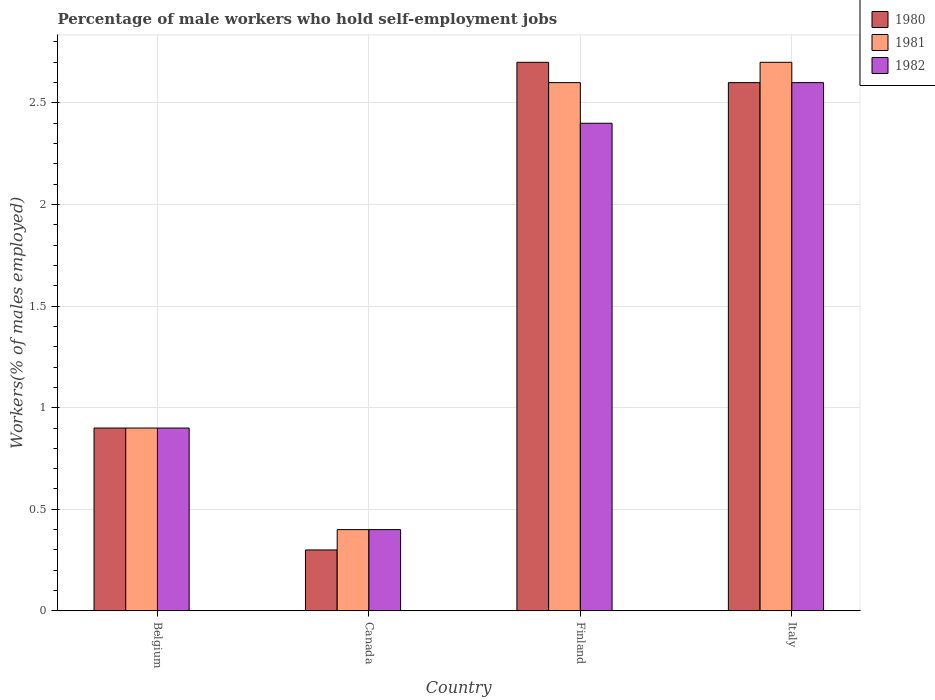How many different coloured bars are there?
Your response must be concise. 3. How many groups of bars are there?
Keep it short and to the point. 4. Are the number of bars per tick equal to the number of legend labels?
Your answer should be very brief. Yes. Are the number of bars on each tick of the X-axis equal?
Make the answer very short. Yes. How many bars are there on the 3rd tick from the left?
Offer a very short reply. 3. How many bars are there on the 1st tick from the right?
Your answer should be compact. 3. What is the label of the 3rd group of bars from the left?
Offer a terse response. Finland. In how many cases, is the number of bars for a given country not equal to the number of legend labels?
Provide a short and direct response. 0. What is the percentage of self-employed male workers in 1982 in Italy?
Offer a very short reply. 2.6. Across all countries, what is the maximum percentage of self-employed male workers in 1981?
Your response must be concise. 2.7. Across all countries, what is the minimum percentage of self-employed male workers in 1982?
Give a very brief answer. 0.4. In which country was the percentage of self-employed male workers in 1981 maximum?
Offer a very short reply. Italy. In which country was the percentage of self-employed male workers in 1982 minimum?
Provide a short and direct response. Canada. What is the total percentage of self-employed male workers in 1980 in the graph?
Keep it short and to the point. 6.5. What is the difference between the percentage of self-employed male workers in 1980 in Belgium and that in Finland?
Ensure brevity in your answer.  -1.8. What is the difference between the percentage of self-employed male workers in 1980 in Finland and the percentage of self-employed male workers in 1982 in Canada?
Provide a short and direct response. 2.3. What is the average percentage of self-employed male workers in 1980 per country?
Provide a succinct answer. 1.62. What is the difference between the percentage of self-employed male workers of/in 1982 and percentage of self-employed male workers of/in 1981 in Italy?
Provide a short and direct response. -0.1. What is the ratio of the percentage of self-employed male workers in 1981 in Belgium to that in Italy?
Your response must be concise. 0.33. Is the percentage of self-employed male workers in 1982 in Finland less than that in Italy?
Provide a succinct answer. Yes. What is the difference between the highest and the second highest percentage of self-employed male workers in 1981?
Keep it short and to the point. -1.8. What is the difference between the highest and the lowest percentage of self-employed male workers in 1982?
Offer a very short reply. 2.2. In how many countries, is the percentage of self-employed male workers in 1981 greater than the average percentage of self-employed male workers in 1981 taken over all countries?
Keep it short and to the point. 2. Is it the case that in every country, the sum of the percentage of self-employed male workers in 1980 and percentage of self-employed male workers in 1982 is greater than the percentage of self-employed male workers in 1981?
Provide a short and direct response. Yes. How many bars are there?
Give a very brief answer. 12. How many countries are there in the graph?
Your response must be concise. 4. What is the difference between two consecutive major ticks on the Y-axis?
Offer a very short reply. 0.5. Does the graph contain any zero values?
Your answer should be very brief. No. Does the graph contain grids?
Your answer should be compact. Yes. What is the title of the graph?
Your answer should be compact. Percentage of male workers who hold self-employment jobs. What is the label or title of the Y-axis?
Give a very brief answer. Workers(% of males employed). What is the Workers(% of males employed) of 1980 in Belgium?
Provide a succinct answer. 0.9. What is the Workers(% of males employed) in 1981 in Belgium?
Make the answer very short. 0.9. What is the Workers(% of males employed) in 1982 in Belgium?
Ensure brevity in your answer.  0.9. What is the Workers(% of males employed) in 1980 in Canada?
Your answer should be very brief. 0.3. What is the Workers(% of males employed) of 1981 in Canada?
Provide a succinct answer. 0.4. What is the Workers(% of males employed) in 1982 in Canada?
Make the answer very short. 0.4. What is the Workers(% of males employed) in 1980 in Finland?
Offer a terse response. 2.7. What is the Workers(% of males employed) in 1981 in Finland?
Offer a terse response. 2.6. What is the Workers(% of males employed) in 1982 in Finland?
Ensure brevity in your answer.  2.4. What is the Workers(% of males employed) in 1980 in Italy?
Offer a very short reply. 2.6. What is the Workers(% of males employed) of 1981 in Italy?
Give a very brief answer. 2.7. What is the Workers(% of males employed) in 1982 in Italy?
Provide a succinct answer. 2.6. Across all countries, what is the maximum Workers(% of males employed) in 1980?
Your response must be concise. 2.7. Across all countries, what is the maximum Workers(% of males employed) of 1981?
Your answer should be compact. 2.7. Across all countries, what is the maximum Workers(% of males employed) in 1982?
Ensure brevity in your answer.  2.6. Across all countries, what is the minimum Workers(% of males employed) in 1980?
Keep it short and to the point. 0.3. Across all countries, what is the minimum Workers(% of males employed) in 1981?
Offer a very short reply. 0.4. Across all countries, what is the minimum Workers(% of males employed) of 1982?
Offer a very short reply. 0.4. What is the total Workers(% of males employed) in 1981 in the graph?
Your answer should be very brief. 6.6. What is the total Workers(% of males employed) in 1982 in the graph?
Your answer should be compact. 6.3. What is the difference between the Workers(% of males employed) of 1980 in Belgium and that in Canada?
Offer a very short reply. 0.6. What is the difference between the Workers(% of males employed) in 1981 in Belgium and that in Canada?
Your answer should be very brief. 0.5. What is the difference between the Workers(% of males employed) in 1982 in Belgium and that in Canada?
Your answer should be very brief. 0.5. What is the difference between the Workers(% of males employed) in 1980 in Belgium and that in Italy?
Your response must be concise. -1.7. What is the difference between the Workers(% of males employed) of 1981 in Belgium and that in Italy?
Your answer should be very brief. -1.8. What is the difference between the Workers(% of males employed) of 1980 in Canada and that in Finland?
Provide a short and direct response. -2.4. What is the difference between the Workers(% of males employed) in 1981 in Canada and that in Finland?
Offer a very short reply. -2.2. What is the difference between the Workers(% of males employed) of 1980 in Canada and that in Italy?
Provide a succinct answer. -2.3. What is the difference between the Workers(% of males employed) in 1981 in Canada and that in Italy?
Provide a short and direct response. -2.3. What is the difference between the Workers(% of males employed) of 1982 in Canada and that in Italy?
Your answer should be very brief. -2.2. What is the difference between the Workers(% of males employed) of 1981 in Finland and that in Italy?
Provide a short and direct response. -0.1. What is the difference between the Workers(% of males employed) of 1982 in Finland and that in Italy?
Provide a succinct answer. -0.2. What is the difference between the Workers(% of males employed) in 1981 in Belgium and the Workers(% of males employed) in 1982 in Canada?
Make the answer very short. 0.5. What is the difference between the Workers(% of males employed) of 1980 in Belgium and the Workers(% of males employed) of 1981 in Finland?
Provide a short and direct response. -1.7. What is the difference between the Workers(% of males employed) of 1981 in Belgium and the Workers(% of males employed) of 1982 in Finland?
Provide a short and direct response. -1.5. What is the difference between the Workers(% of males employed) in 1980 in Belgium and the Workers(% of males employed) in 1981 in Italy?
Provide a succinct answer. -1.8. What is the difference between the Workers(% of males employed) of 1981 in Belgium and the Workers(% of males employed) of 1982 in Italy?
Your answer should be compact. -1.7. What is the difference between the Workers(% of males employed) of 1981 in Canada and the Workers(% of males employed) of 1982 in Finland?
Give a very brief answer. -2. What is the difference between the Workers(% of males employed) of 1981 in Canada and the Workers(% of males employed) of 1982 in Italy?
Your answer should be very brief. -2.2. What is the difference between the Workers(% of males employed) in 1980 in Finland and the Workers(% of males employed) in 1981 in Italy?
Make the answer very short. 0. What is the difference between the Workers(% of males employed) of 1980 in Finland and the Workers(% of males employed) of 1982 in Italy?
Offer a very short reply. 0.1. What is the average Workers(% of males employed) of 1980 per country?
Keep it short and to the point. 1.62. What is the average Workers(% of males employed) in 1981 per country?
Give a very brief answer. 1.65. What is the average Workers(% of males employed) in 1982 per country?
Make the answer very short. 1.57. What is the difference between the Workers(% of males employed) in 1980 and Workers(% of males employed) in 1981 in Belgium?
Provide a short and direct response. 0. What is the difference between the Workers(% of males employed) of 1980 and Workers(% of males employed) of 1982 in Belgium?
Offer a very short reply. 0. What is the difference between the Workers(% of males employed) of 1980 and Workers(% of males employed) of 1982 in Canada?
Offer a terse response. -0.1. What is the difference between the Workers(% of males employed) of 1981 and Workers(% of males employed) of 1982 in Canada?
Provide a succinct answer. 0. What is the difference between the Workers(% of males employed) of 1980 and Workers(% of males employed) of 1982 in Italy?
Your answer should be compact. 0. What is the difference between the Workers(% of males employed) in 1981 and Workers(% of males employed) in 1982 in Italy?
Provide a short and direct response. 0.1. What is the ratio of the Workers(% of males employed) in 1981 in Belgium to that in Canada?
Ensure brevity in your answer.  2.25. What is the ratio of the Workers(% of males employed) in 1982 in Belgium to that in Canada?
Keep it short and to the point. 2.25. What is the ratio of the Workers(% of males employed) of 1980 in Belgium to that in Finland?
Your answer should be very brief. 0.33. What is the ratio of the Workers(% of males employed) in 1981 in Belgium to that in Finland?
Ensure brevity in your answer.  0.35. What is the ratio of the Workers(% of males employed) of 1982 in Belgium to that in Finland?
Offer a terse response. 0.38. What is the ratio of the Workers(% of males employed) in 1980 in Belgium to that in Italy?
Your answer should be very brief. 0.35. What is the ratio of the Workers(% of males employed) of 1982 in Belgium to that in Italy?
Ensure brevity in your answer.  0.35. What is the ratio of the Workers(% of males employed) of 1981 in Canada to that in Finland?
Make the answer very short. 0.15. What is the ratio of the Workers(% of males employed) in 1982 in Canada to that in Finland?
Make the answer very short. 0.17. What is the ratio of the Workers(% of males employed) in 1980 in Canada to that in Italy?
Your answer should be compact. 0.12. What is the ratio of the Workers(% of males employed) in 1981 in Canada to that in Italy?
Your response must be concise. 0.15. What is the ratio of the Workers(% of males employed) in 1982 in Canada to that in Italy?
Your response must be concise. 0.15. What is the difference between the highest and the second highest Workers(% of males employed) of 1982?
Provide a short and direct response. 0.2. What is the difference between the highest and the lowest Workers(% of males employed) in 1980?
Provide a succinct answer. 2.4. What is the difference between the highest and the lowest Workers(% of males employed) of 1981?
Your response must be concise. 2.3. 